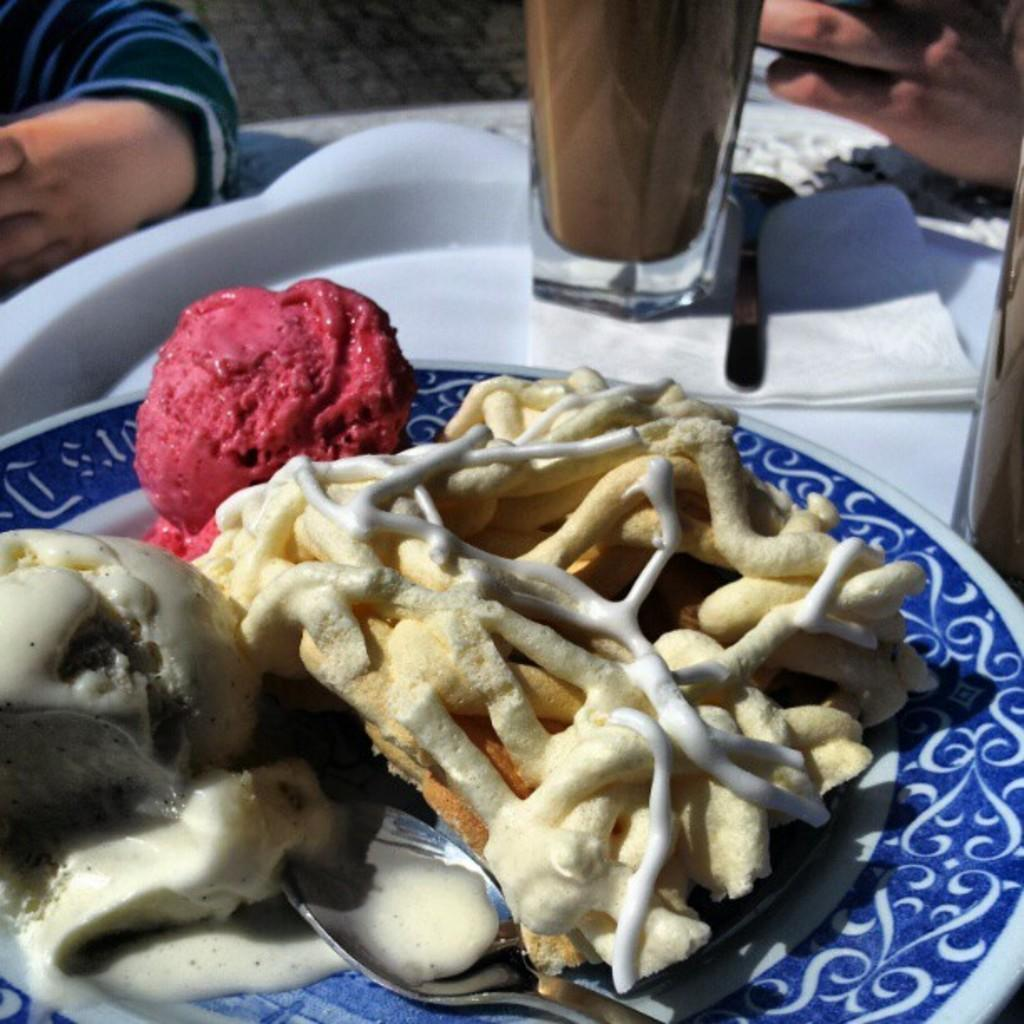What utensil can be seen on the table in the image? There is a spoon on the table in the image. What type of paper is present on the table? There is tissue paper on the table. What type of container is on the table? There is a glass on the table. What type of dishware is on the table? There is a plate on the table. What type of dessert is on the table? There is ice-cream on the table. What type of food is on the table? There is food on the table. Whose hands are visible in the image? People's hands are visible in the image. What type of ornament is hanging from the quince tree in the garden? There is no quince tree, garden, or ornament present in the image. 